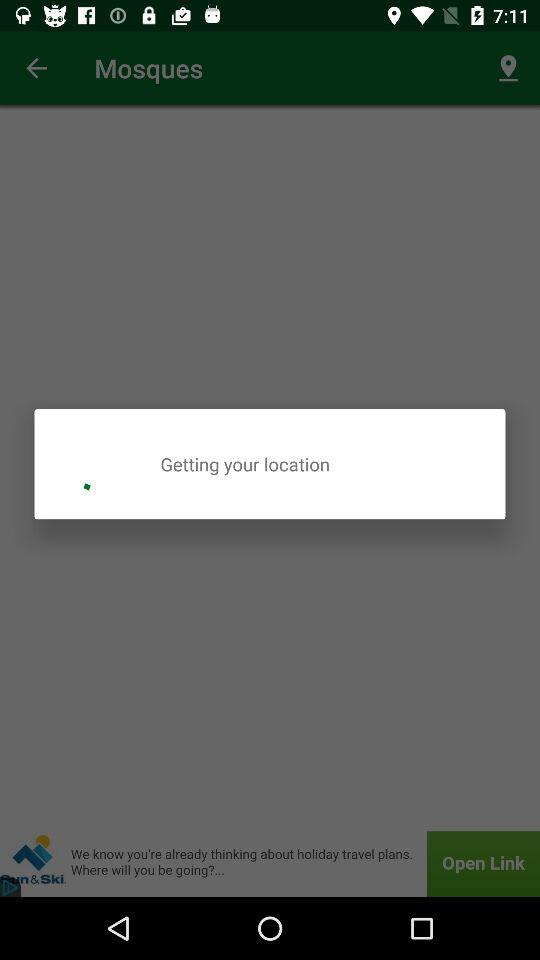What application is asking for permission? The application asking for permission is "Muslim Pro". 